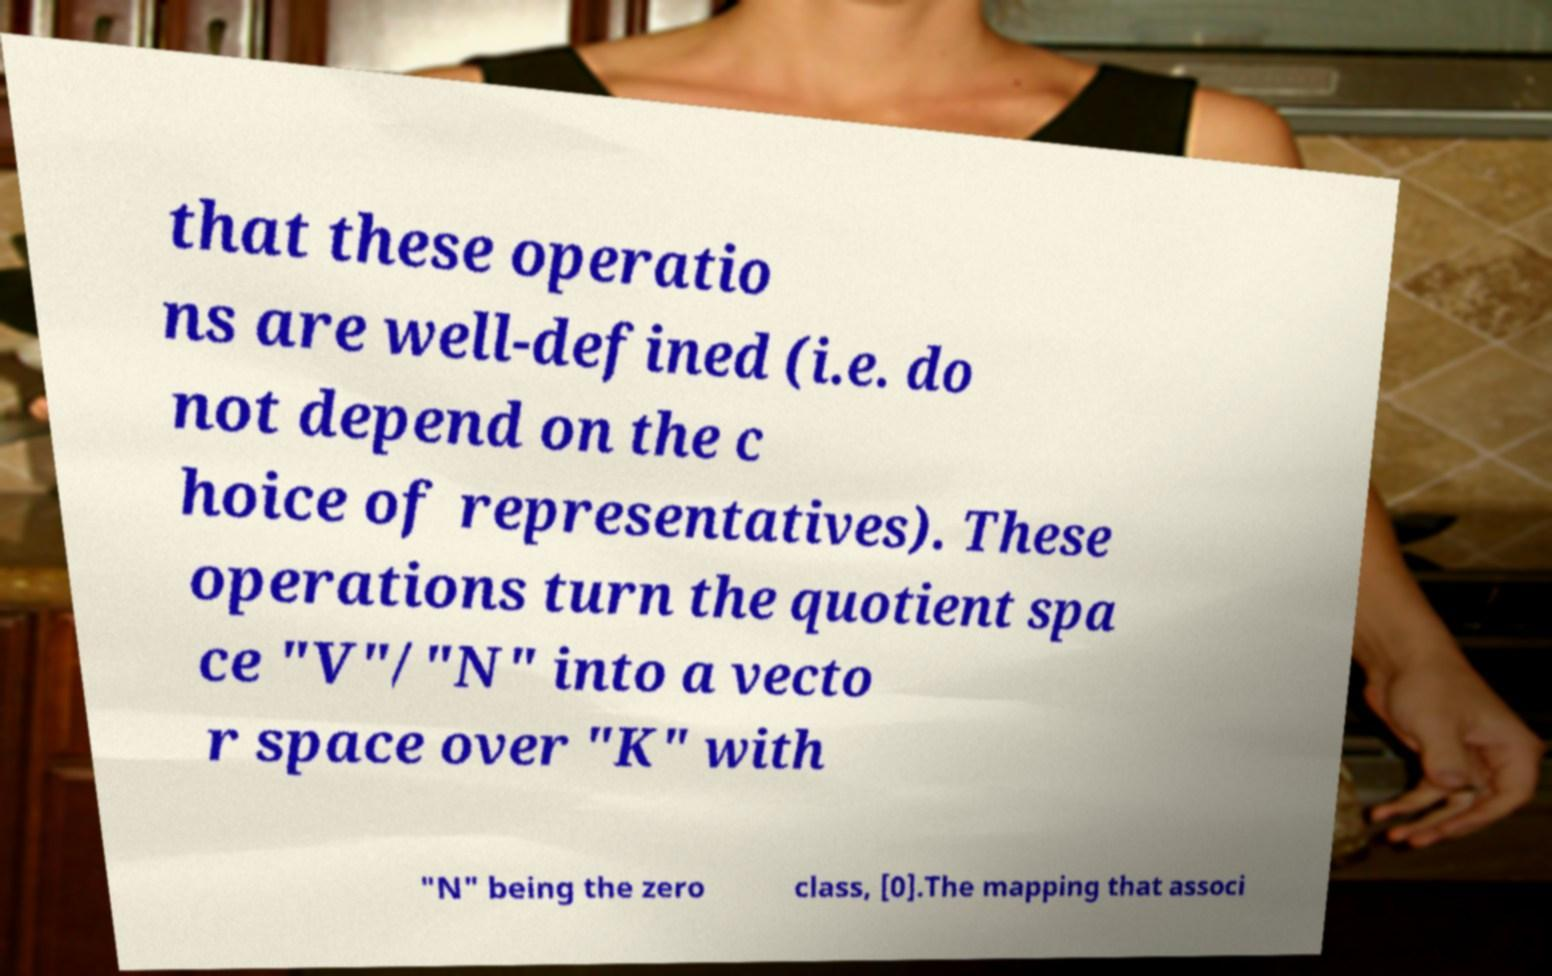For documentation purposes, I need the text within this image transcribed. Could you provide that? that these operatio ns are well-defined (i.e. do not depend on the c hoice of representatives). These operations turn the quotient spa ce "V"/"N" into a vecto r space over "K" with "N" being the zero class, [0].The mapping that associ 